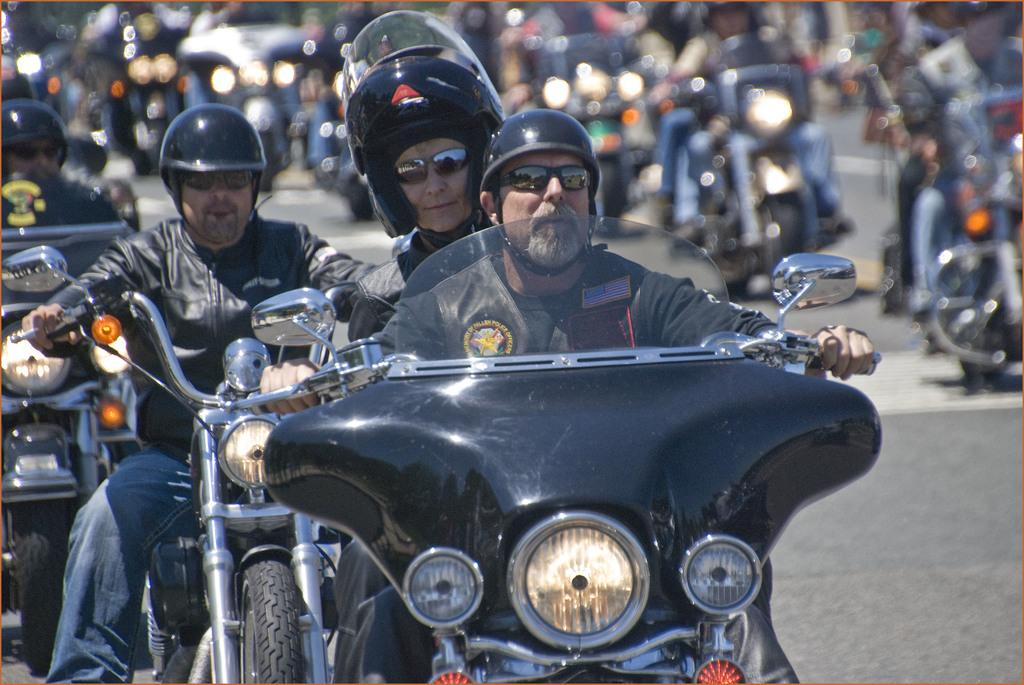What are the people in the image doing? The people in the image are riding bikes. Where are the bikes located? The bikes are on a road. How many people are in the group? The number of people in the group cannot be determined from the provided facts. What type of celery can be seen growing on the side of the road in the image? There is no celery present in the image; it features a group of people riding bikes on a road. 